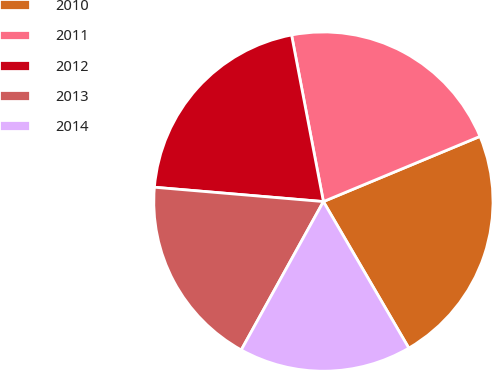<chart> <loc_0><loc_0><loc_500><loc_500><pie_chart><fcel>2010<fcel>2011<fcel>2012<fcel>2013<fcel>2014<nl><fcel>22.88%<fcel>21.73%<fcel>20.65%<fcel>18.3%<fcel>16.45%<nl></chart> 